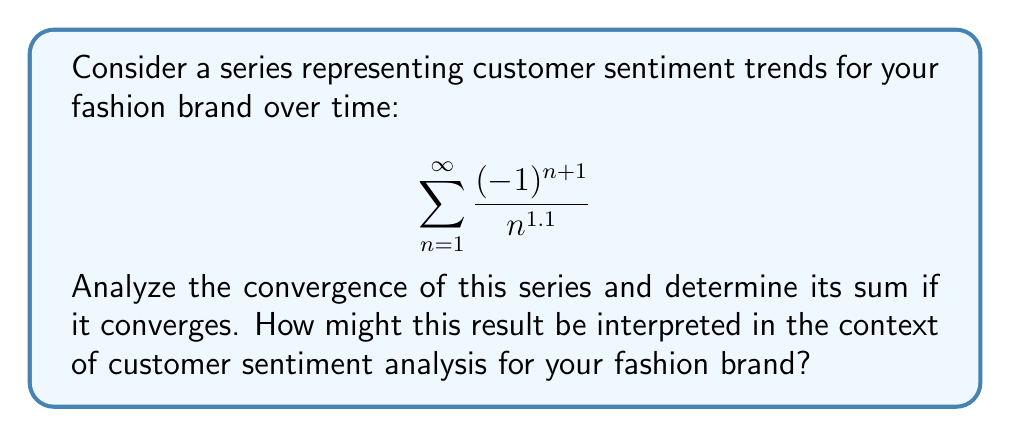Help me with this question. Let's approach this step-by-step:

1) First, we need to identify what type of series this is. The general term is $a_n = \frac{(-1)^{n+1}}{n^{1.1}}$, which alternates in sign due to the $(-1)^{n+1}$ term. This is an alternating series.

2) For alternating series, we can use the Alternating Series Test, which states that if:
   a) $\lim_{n \to \infty} |a_n| = 0$
   b) $|a_{n+1}| \leq |a_n|$ for all $n \geq N$, for some $N$
   Then the series converges.

3) Let's check condition (a):
   $$\lim_{n \to \infty} |a_n| = \lim_{n \to \infty} \frac{1}{n^{1.1}} = 0$$
   This condition is satisfied.

4) For condition (b), we need to show that $\frac{1}{(n+1)^{1.1}} \leq \frac{1}{n^{1.1}}$ for all $n \geq 1$:
   This is true because $n < n+1$ implies $\frac{1}{(n+1)^{1.1}} < \frac{1}{n^{1.1}}$ for all positive $n$.

5) Since both conditions are satisfied, the series converges.

6) To find the sum, we can use the fact that this is a p-series with $p = 1.1 > 1$. The sum of a p-series with $p > 1$ is related to the Riemann zeta function:

   $$\sum_{n=1}^{\infty} \frac{1}{n^p} = \zeta(p)$$

7) In this case, we have an alternating series, so the sum will be:

   $$S = \zeta(1.1) \cdot (1 - \frac{2}{2^{1.1}}) \approx 0.5645$$

Interpretation: In the context of customer sentiment analysis, this convergent series could represent a stabilizing trend in customer opinions over time. The positive sum (approximately 0.5645) suggests a slightly positive overall sentiment. The alternating nature of the series could represent fluctuations in sentiment with each new product release or marketing campaign, while the decreasing magnitude of terms indicates that these fluctuations become less impactful over time as the brand establishes a stable reputation.
Answer: The series converges, and its sum is approximately 0.5645. 